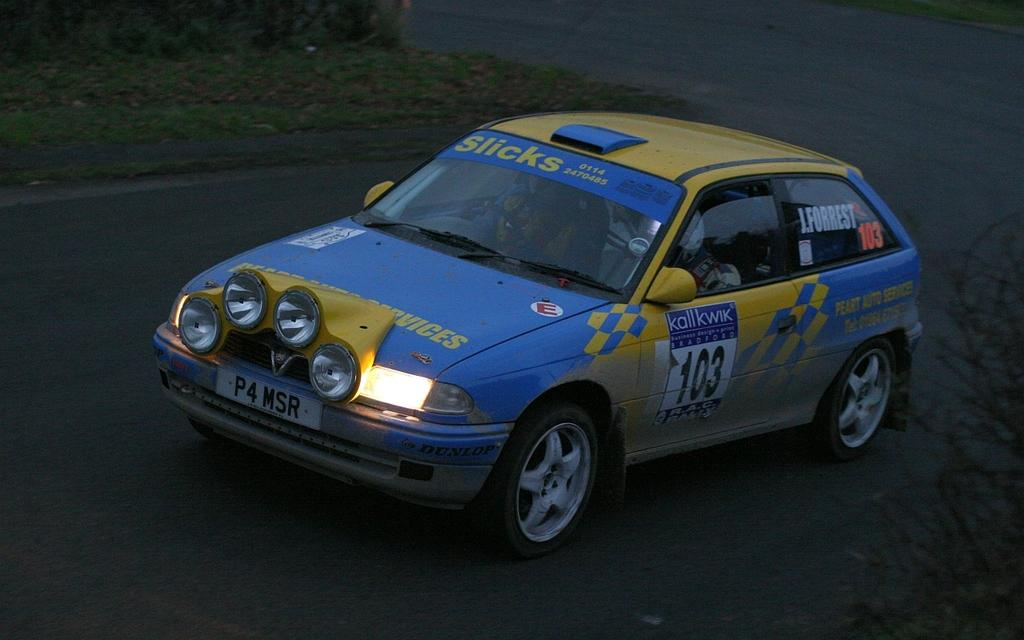What is the main subject of the image? The main subject of the image is a car on a road. Are there any passengers in the car? Yes, there are people sitting in the car. What type of landscape can be seen in the image? There is a grassland visible in the top left corner of the image. What grade of wax is being used to polish the car in the image? There is no indication in the image that the car is being polished, nor is there any mention of wax. 